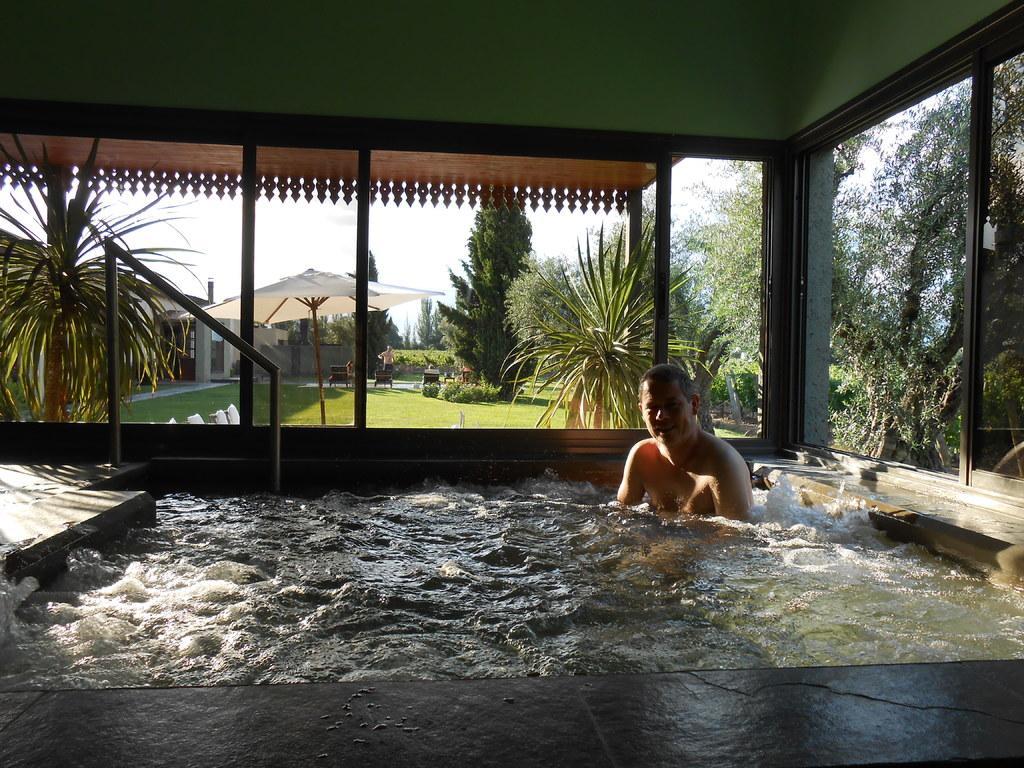Describe this image in one or two sentences. As we can see there is a pool in which a man is bathing and behind him there is a garden in which the ground is covered with grass and there is white umbrella in between and behind it there are trees and beside the house there is trees all over around. 